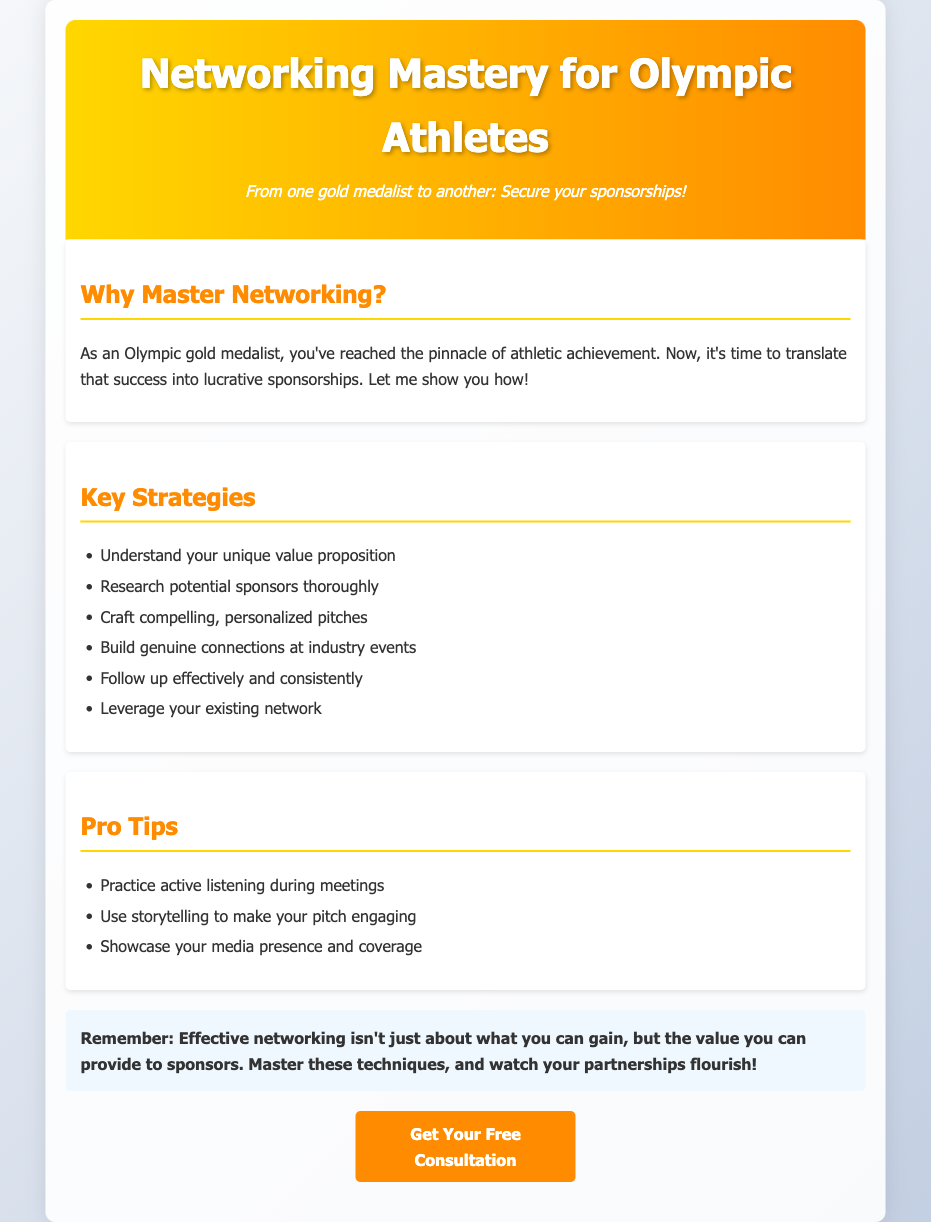What is the title of the document? The title of the document is located in the header section and indicates the main focus of the content.
Answer: Networking Mastery for Olympic Athletes What is the main purpose of the document? The main purpose is outlined in the introduction, highlighting the need for Olympic athletes to secure sponsorships.
Answer: Secure your sponsorships How many key strategies are listed? The number of key strategies can be determined by counting the items in the "Key Strategies" section.
Answer: Six What is one of the pro tips mentioned? The pro tips section presents useful guidance, and any item listed there can be an answer.
Answer: Practice active listening during meetings What color is used in the header background? The color in the header can be identified when observing the visual design, focusing on the gradient mentioned.
Answer: Gold and orange What should you leverage to help secure sponsorships? This answer is found in the "Key Strategies" section, emphasizing the importance of existing relationships.
Answer: Your existing network What does effective networking require according to the conclusion? The conclusion underscores an important aspect of networking mentioned in a key takeaway.
Answer: Value you can provide How is the document styled? The styling refers to the visual design choices communicated in the document, noticeable by the layout and use of color.
Answer: Advertisement 